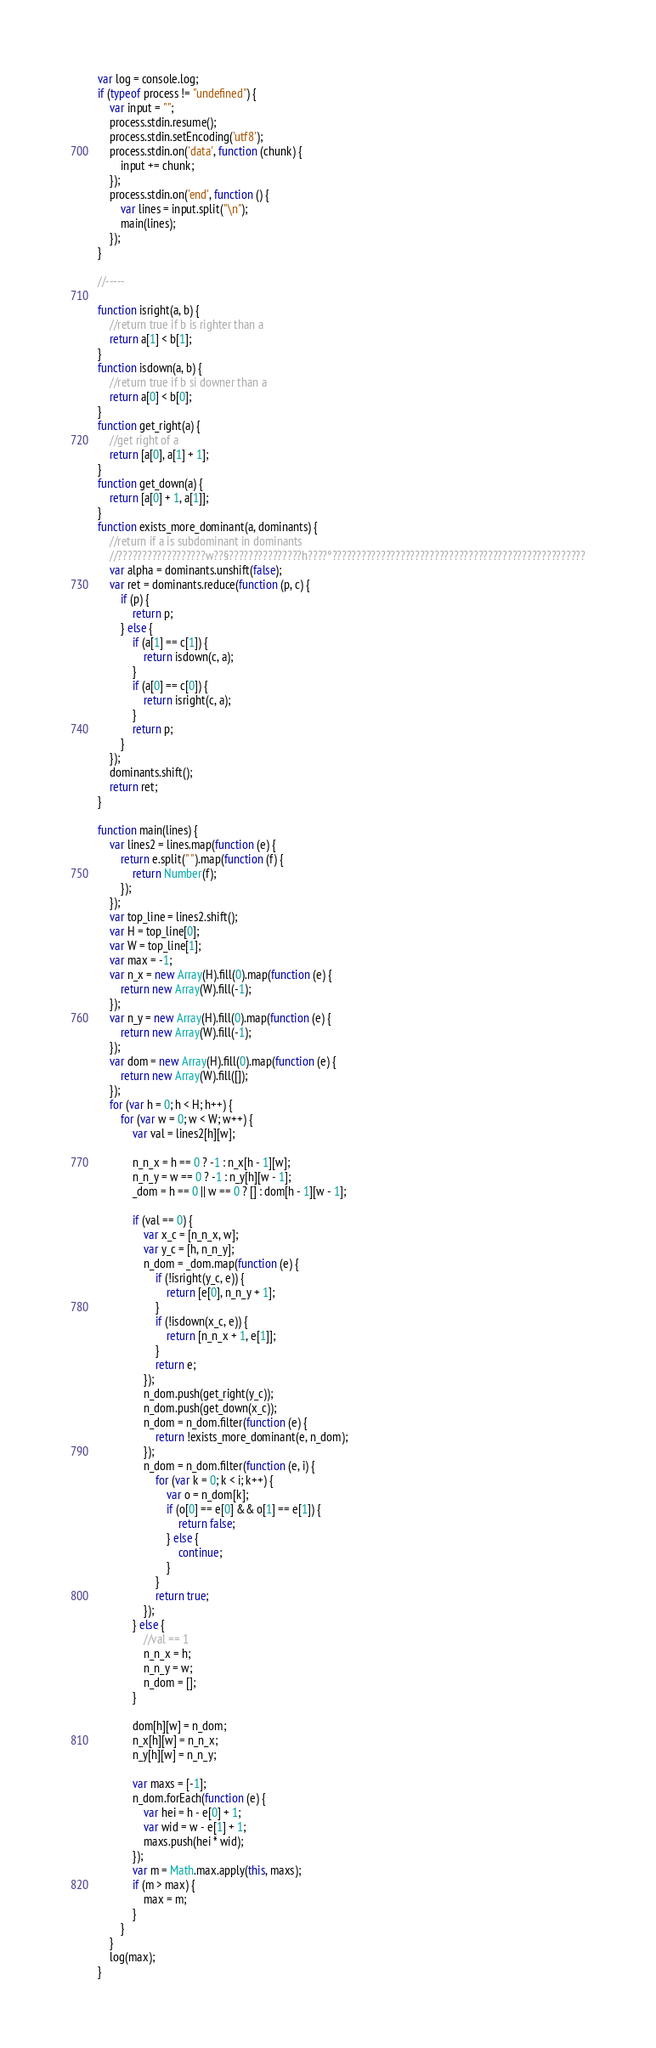<code> <loc_0><loc_0><loc_500><loc_500><_JavaScript_>var log = console.log;
if (typeof process != "undefined") {
	var input = "";
	process.stdin.resume();
	process.stdin.setEncoding('utf8');
	process.stdin.on('data', function (chunk) {
		input += chunk;
	});
	process.stdin.on('end', function () {
		var lines = input.split("\n");
		main(lines);
	});
}

//-----

function isright(a, b) {
	//return true if b is righter than a
	return a[1] < b[1];
}
function isdown(a, b) {
	//return true if b si downer than a
	return a[0] < b[0];
}
function get_right(a) {
	//get right of a
	return [a[0], a[1] + 1];
}
function get_down(a) {
	return [a[0] + 1, a[1]];
}
function exists_more_dominant(a, dominants) {
	//return if a is subdominant in dominants
	//??????????????????w??§???????????????h????°????????????????????????????????????????????????????
	var alpha = dominants.unshift(false);
	var ret = dominants.reduce(function (p, c) {
		if (p) {
			return p;
		} else {
			if (a[1] == c[1]) {
				return isdown(c, a);
			}
			if (a[0] == c[0]) {
				return isright(c, a);
			}
			return p;
		}
	});
	dominants.shift();
	return ret;
}

function main(lines) {
	var lines2 = lines.map(function (e) {
		return e.split(" ").map(function (f) {
			return Number(f);
		});
	});
	var top_line = lines2.shift();
	var H = top_line[0];
	var W = top_line[1];
	var max = -1;
	var n_x = new Array(H).fill(0).map(function (e) {
		return new Array(W).fill(-1);
	});
	var n_y = new Array(H).fill(0).map(function (e) {
		return new Array(W).fill(-1);
	});
	var dom = new Array(H).fill(0).map(function (e) {
		return new Array(W).fill([]);
	});
	for (var h = 0; h < H; h++) {
		for (var w = 0; w < W; w++) {
			var val = lines2[h][w];

			n_n_x = h == 0 ? -1 : n_x[h - 1][w];
			n_n_y = w == 0 ? -1 : n_y[h][w - 1];
			_dom = h == 0 || w == 0 ? [] : dom[h - 1][w - 1];

			if (val == 0) {
				var x_c = [n_n_x, w];
				var y_c = [h, n_n_y];
				n_dom = _dom.map(function (e) {
					if (!isright(y_c, e)) {
						return [e[0], n_n_y + 1];
					}
					if (!isdown(x_c, e)) {
						return [n_n_x + 1, e[1]];
					}
					return e;
				});
				n_dom.push(get_right(y_c));
				n_dom.push(get_down(x_c));
				n_dom = n_dom.filter(function (e) {
					return !exists_more_dominant(e, n_dom);
				});
				n_dom = n_dom.filter(function (e, i) {
					for (var k = 0; k < i; k++) {
						var o = n_dom[k];
						if (o[0] == e[0] && o[1] == e[1]) {
							return false;
						} else {
							continue;
						}
					}
					return true;
				});
			} else {
				//val == 1
				n_n_x = h;
				n_n_y = w;
				n_dom = [];
			}

			dom[h][w] = n_dom;
			n_x[h][w] = n_n_x;
			n_y[h][w] = n_n_y;

			var maxs = [-1];
			n_dom.forEach(function (e) {
				var hei = h - e[0] + 1;
				var wid = w - e[1] + 1;
				maxs.push(hei * wid);
			});
			var m = Math.max.apply(this, maxs);
			if (m > max) {
				max = m;
			}
		}
	}
	log(max);
}</code> 